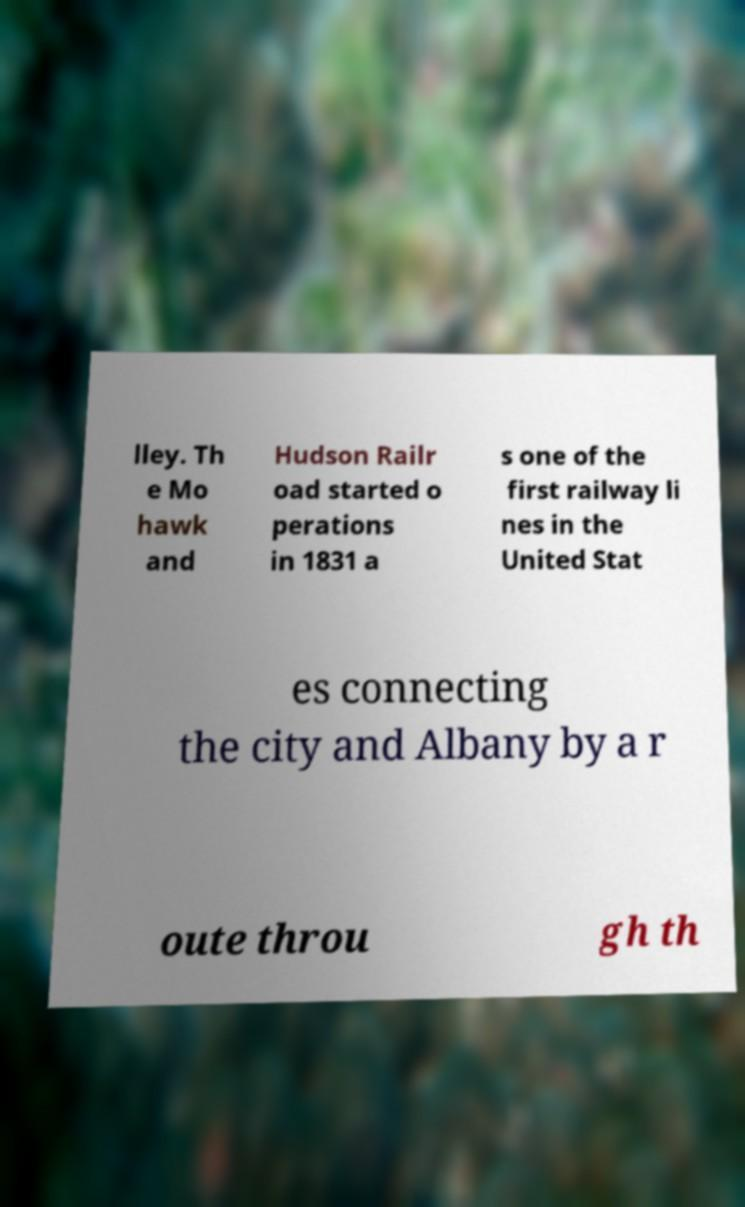What messages or text are displayed in this image? I need them in a readable, typed format. lley. Th e Mo hawk and Hudson Railr oad started o perations in 1831 a s one of the first railway li nes in the United Stat es connecting the city and Albany by a r oute throu gh th 